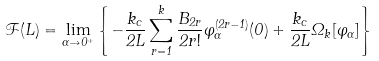Convert formula to latex. <formula><loc_0><loc_0><loc_500><loc_500>\mathcal { F } ( L ) = \lim _ { \alpha \to 0 ^ { + } } \left \{ - \frac { k _ { c } } { 2 L } \sum _ { r = 1 } ^ { k } \frac { B _ { 2 r } } { 2 r ! } \varphi _ { \alpha } ^ { ( 2 r - 1 ) } ( 0 ) + \frac { k _ { c } } { 2 L } \Omega _ { k } [ \varphi _ { \alpha } ] \right \}</formula> 